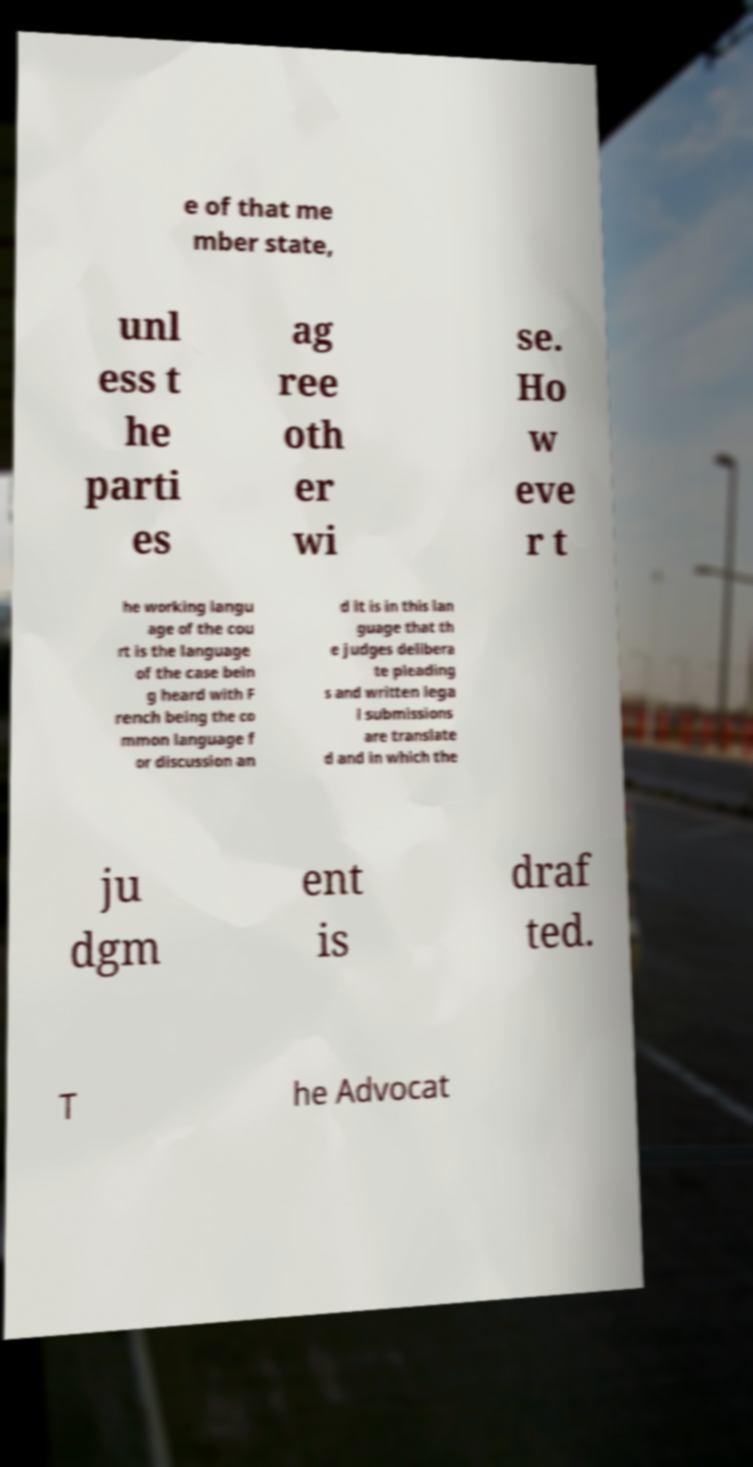Could you assist in decoding the text presented in this image and type it out clearly? e of that me mber state, unl ess t he parti es ag ree oth er wi se. Ho w eve r t he working langu age of the cou rt is the language of the case bein g heard with F rench being the co mmon language f or discussion an d it is in this lan guage that th e judges delibera te pleading s and written lega l submissions are translate d and in which the ju dgm ent is draf ted. T he Advocat 